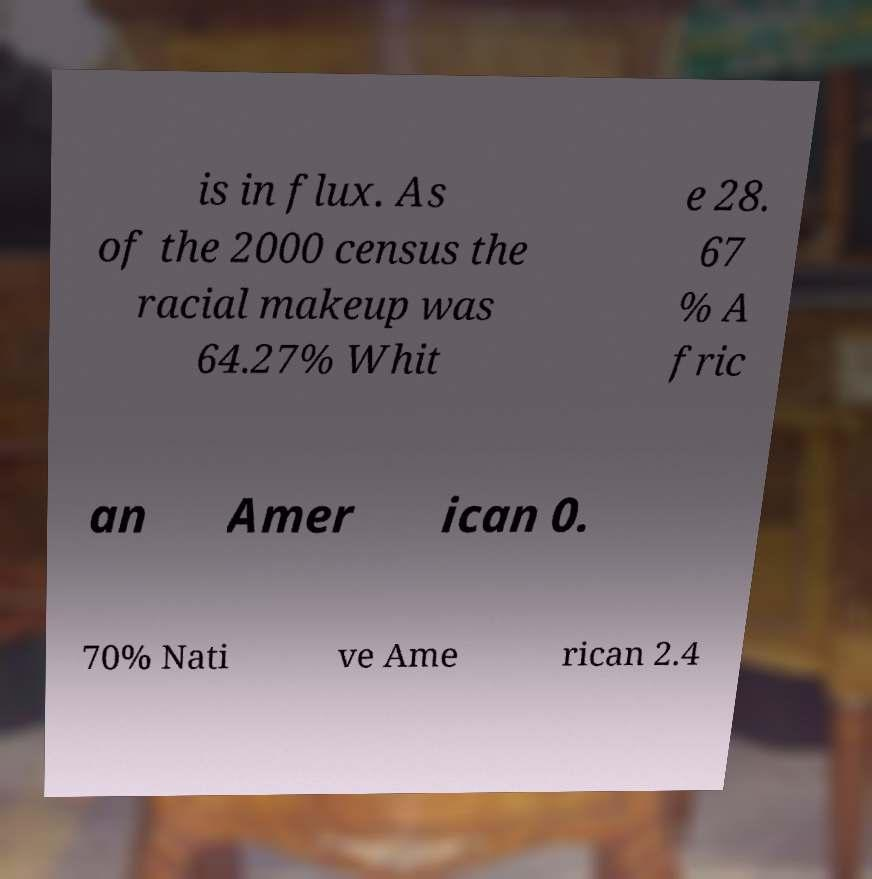I need the written content from this picture converted into text. Can you do that? is in flux. As of the 2000 census the racial makeup was 64.27% Whit e 28. 67 % A fric an Amer ican 0. 70% Nati ve Ame rican 2.4 